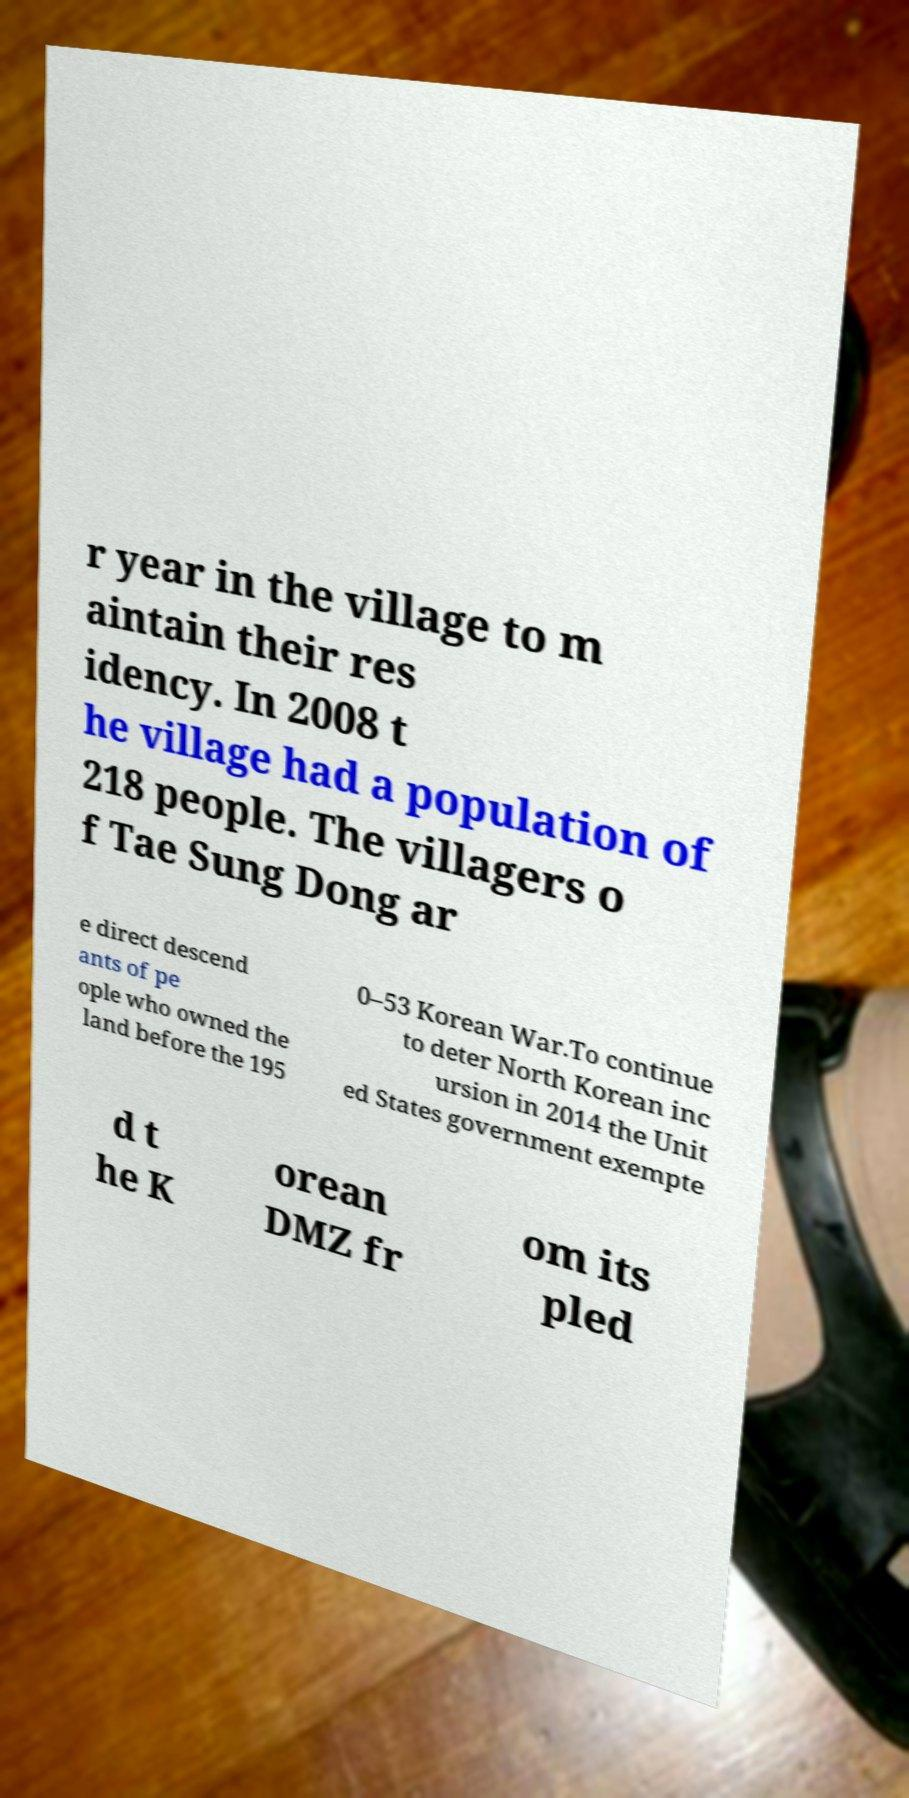Can you accurately transcribe the text from the provided image for me? r year in the village to m aintain their res idency. In 2008 t he village had a population of 218 people. The villagers o f Tae Sung Dong ar e direct descend ants of pe ople who owned the land before the 195 0–53 Korean War.To continue to deter North Korean inc ursion in 2014 the Unit ed States government exempte d t he K orean DMZ fr om its pled 